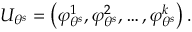<formula> <loc_0><loc_0><loc_500><loc_500>U _ { \theta ^ { s } } = \left ( \varphi _ { \theta ^ { s } } ^ { 1 } , \varphi _ { \theta ^ { s } } ^ { 2 } , \dots , \varphi _ { \theta ^ { s } } ^ { k } \right ) .</formula> 